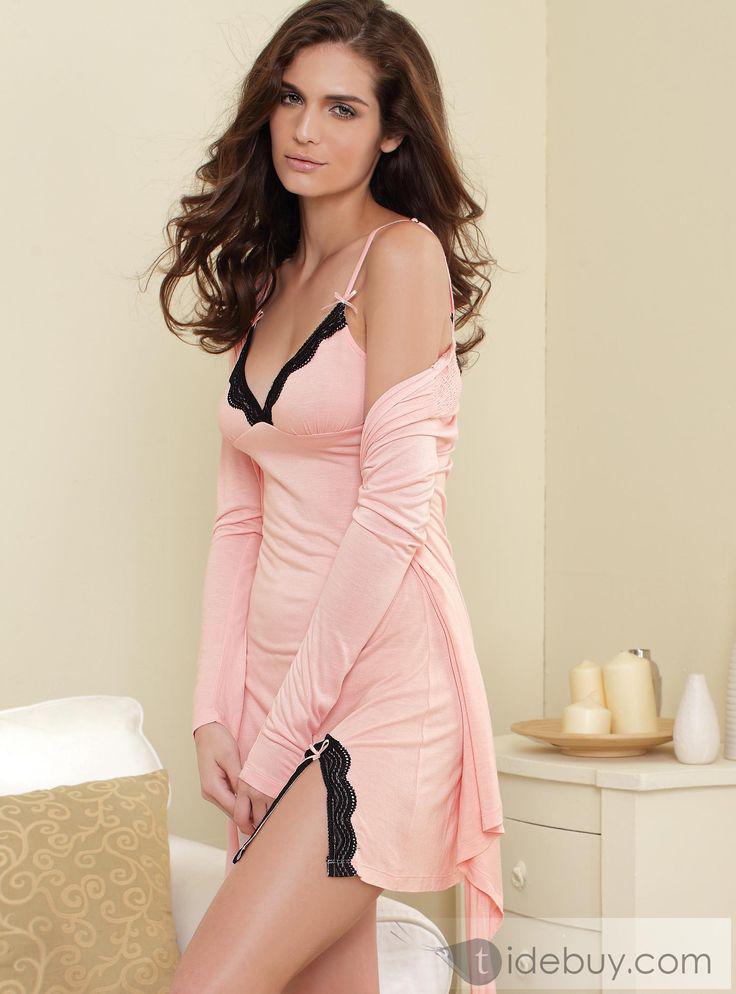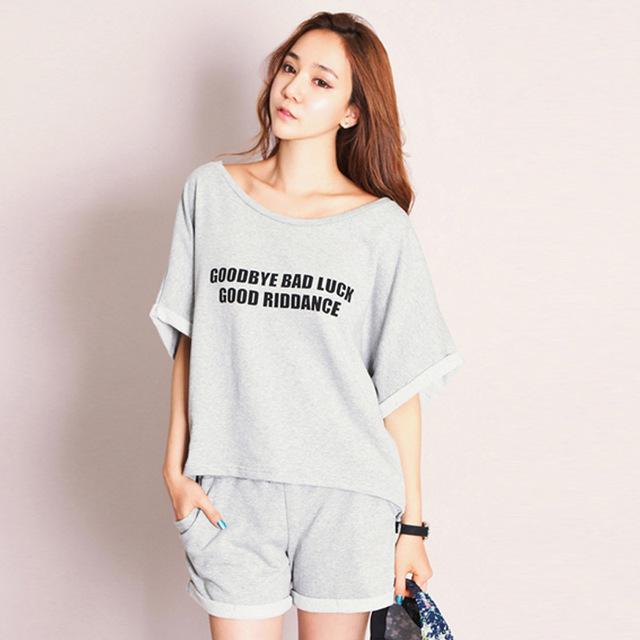The first image is the image on the left, the second image is the image on the right. For the images shown, is this caption "A model wears a long-sleeved robe-type cover-up over intimate apparel in one image." true? Answer yes or no. Yes. The first image is the image on the left, the second image is the image on the right. Analyze the images presented: Is the assertion "One solid color pajama set has a top with straps and lacy bra area, as well as a very short matching bottom." valid? Answer yes or no. No. 